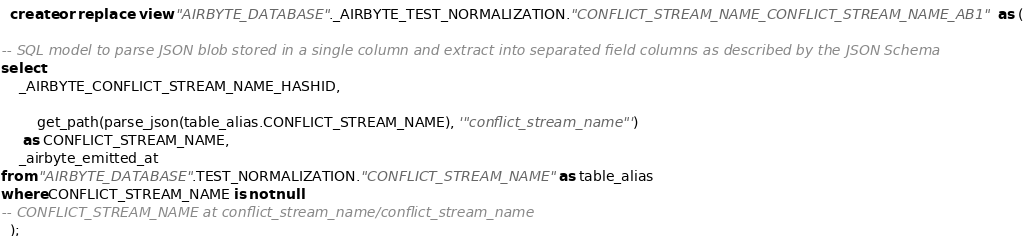Convert code to text. <code><loc_0><loc_0><loc_500><loc_500><_SQL_>
  create or replace  view "AIRBYTE_DATABASE"._AIRBYTE_TEST_NORMALIZATION."CONFLICT_STREAM_NAME_CONFLICT_STREAM_NAME_AB1"  as (
    
-- SQL model to parse JSON blob stored in a single column and extract into separated field columns as described by the JSON Schema
select
    _AIRBYTE_CONFLICT_STREAM_NAME_HASHID,
    
        get_path(parse_json(table_alias.CONFLICT_STREAM_NAME), '"conflict_stream_name"')
     as CONFLICT_STREAM_NAME,
    _airbyte_emitted_at
from "AIRBYTE_DATABASE".TEST_NORMALIZATION."CONFLICT_STREAM_NAME" as table_alias
where CONFLICT_STREAM_NAME is not null
-- CONFLICT_STREAM_NAME at conflict_stream_name/conflict_stream_name
  );
</code> 